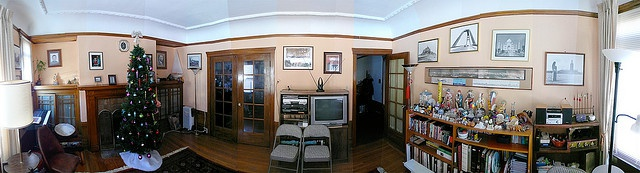Describe the objects in this image and their specific colors. I can see book in darkgray, black, gray, and maroon tones, chair in darkgray, black, and gray tones, chair in darkgray, gray, and black tones, chair in darkgray, black, maroon, and gray tones, and tv in darkgray, black, purple, and gray tones in this image. 